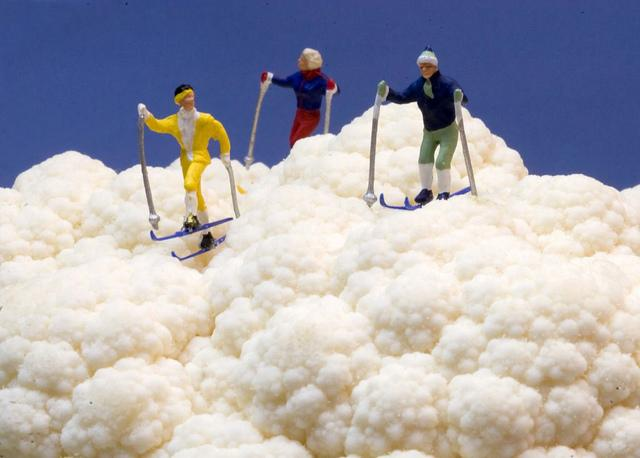What material was used to depict the snow in this art piece? Please explain your reasoning. cotton. Thick spools of cotton were aggregated. 